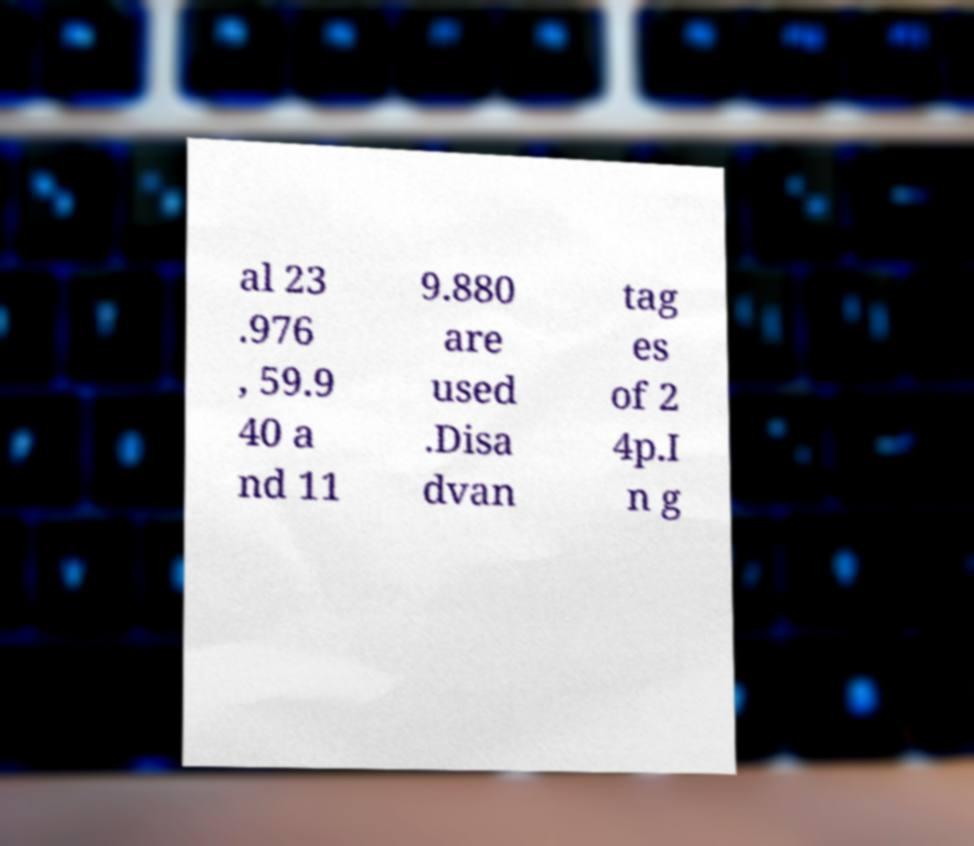Could you extract and type out the text from this image? al 23 .976 , 59.9 40 a nd 11 9.880 are used .Disa dvan tag es of 2 4p.I n g 